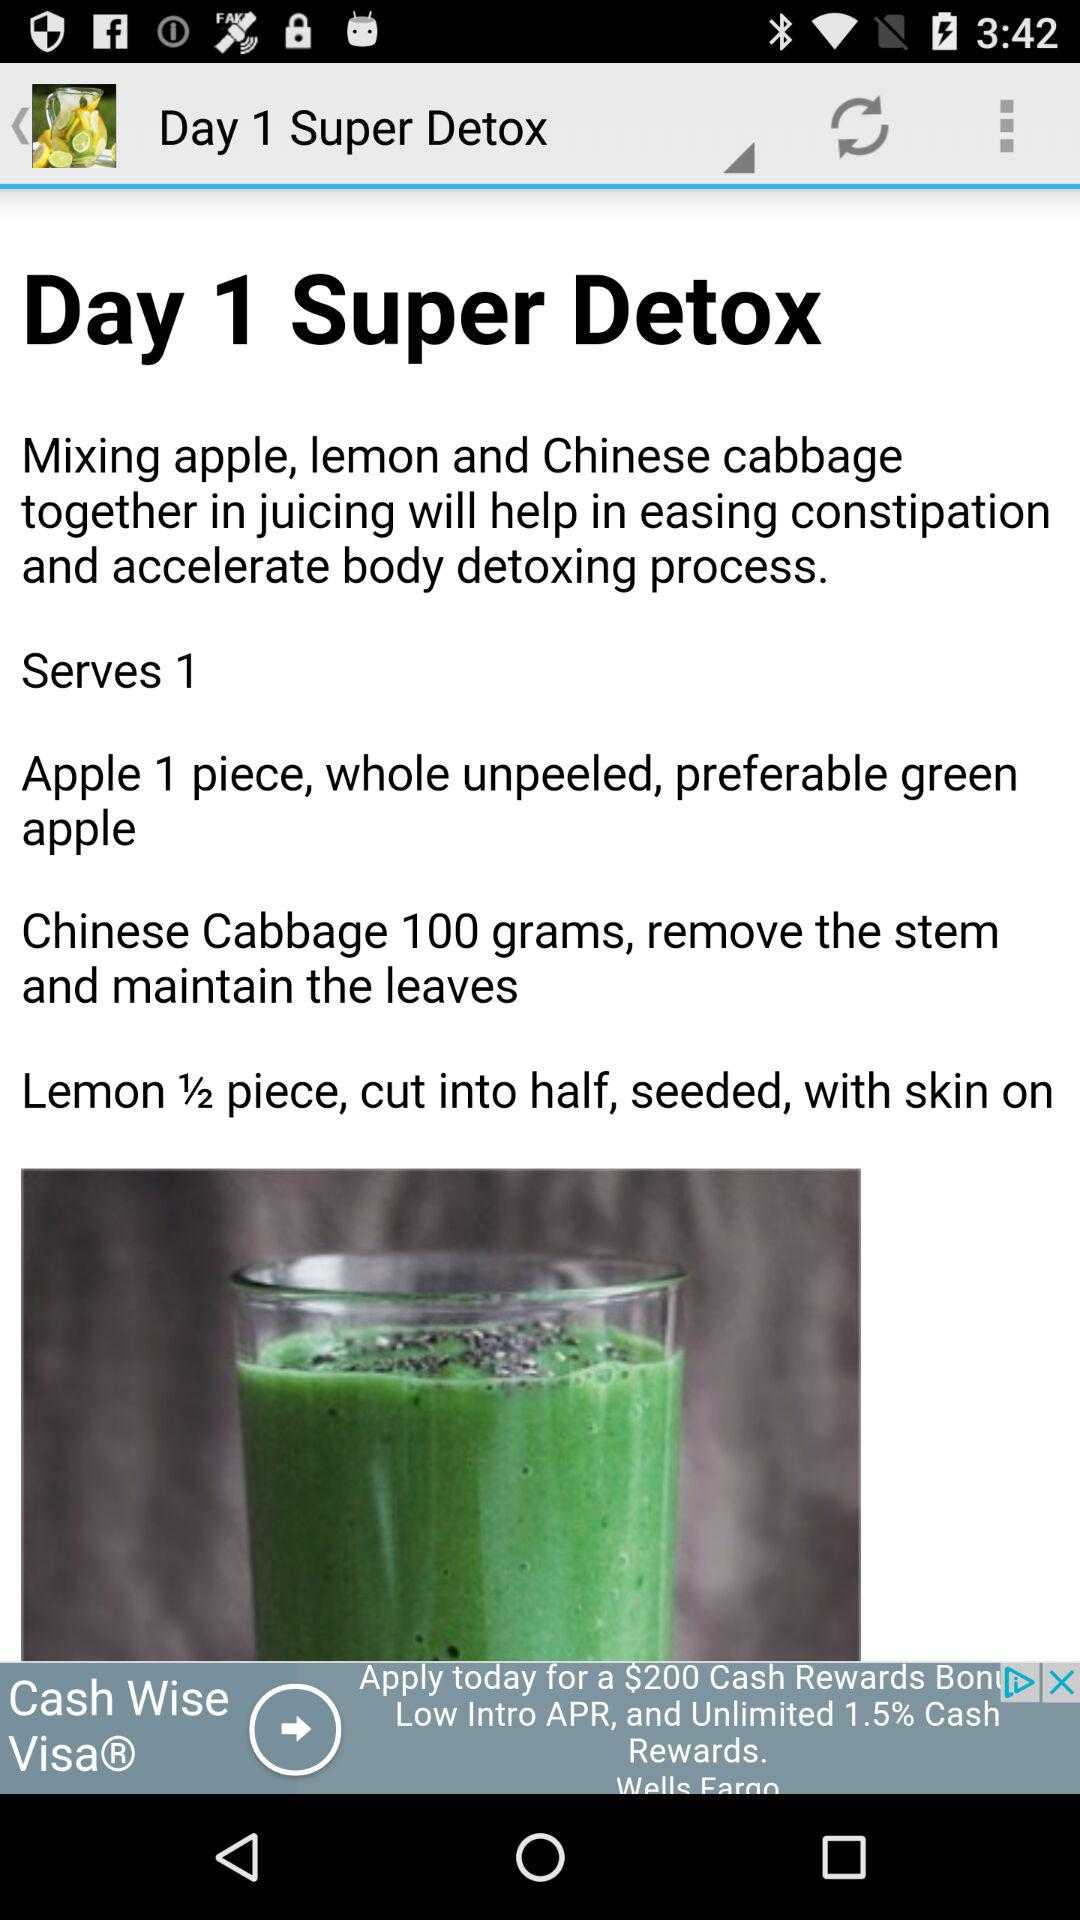What is the quantity of apples required for the "Super Detox"? The quantity of apple required for the "Super Detox" is 1 piece. 